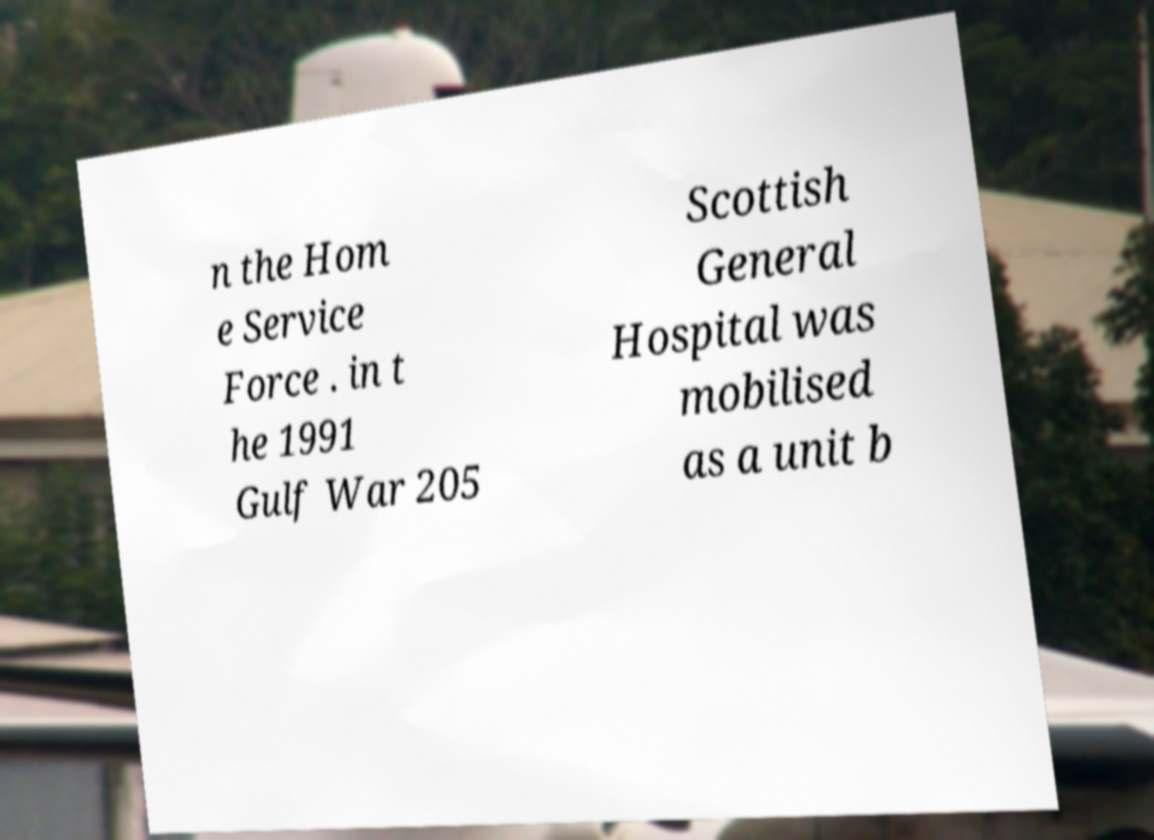Could you assist in decoding the text presented in this image and type it out clearly? n the Hom e Service Force . in t he 1991 Gulf War 205 Scottish General Hospital was mobilised as a unit b 